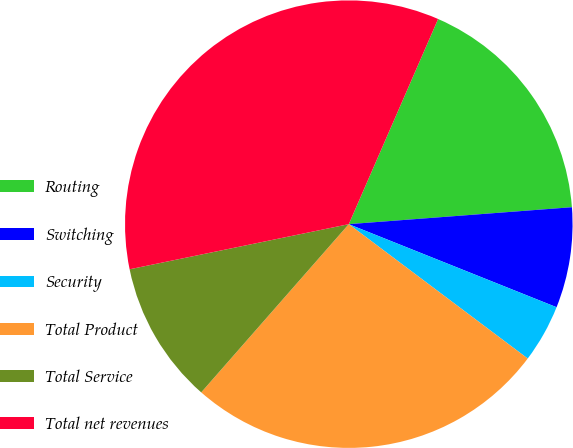Convert chart. <chart><loc_0><loc_0><loc_500><loc_500><pie_chart><fcel>Routing<fcel>Switching<fcel>Security<fcel>Total Product<fcel>Total Service<fcel>Total net revenues<nl><fcel>17.26%<fcel>7.26%<fcel>4.2%<fcel>26.21%<fcel>10.31%<fcel>34.77%<nl></chart> 